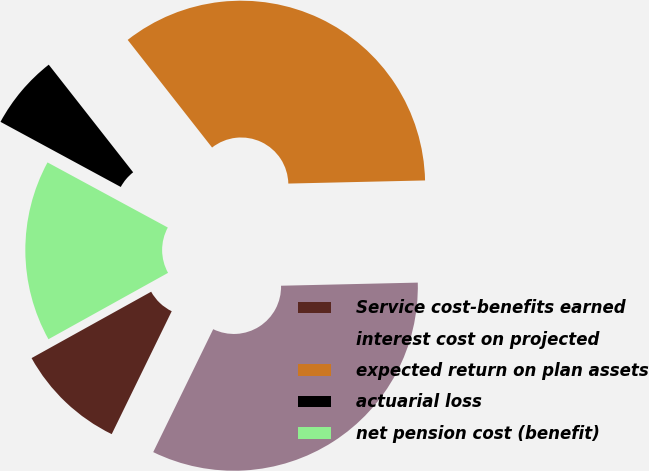<chart> <loc_0><loc_0><loc_500><loc_500><pie_chart><fcel>Service cost-benefits earned<fcel>interest cost on projected<fcel>expected return on plan assets<fcel>actuarial loss<fcel>net pension cost (benefit)<nl><fcel>9.71%<fcel>32.59%<fcel>35.22%<fcel>6.52%<fcel>15.96%<nl></chart> 